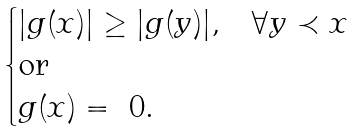<formula> <loc_0><loc_0><loc_500><loc_500>\begin{cases} | g ( x ) | \geq | g ( y ) | , & \forall y \prec x \\ \text {or} & \\ g ( x ) = \ 0 . & \end{cases}</formula> 